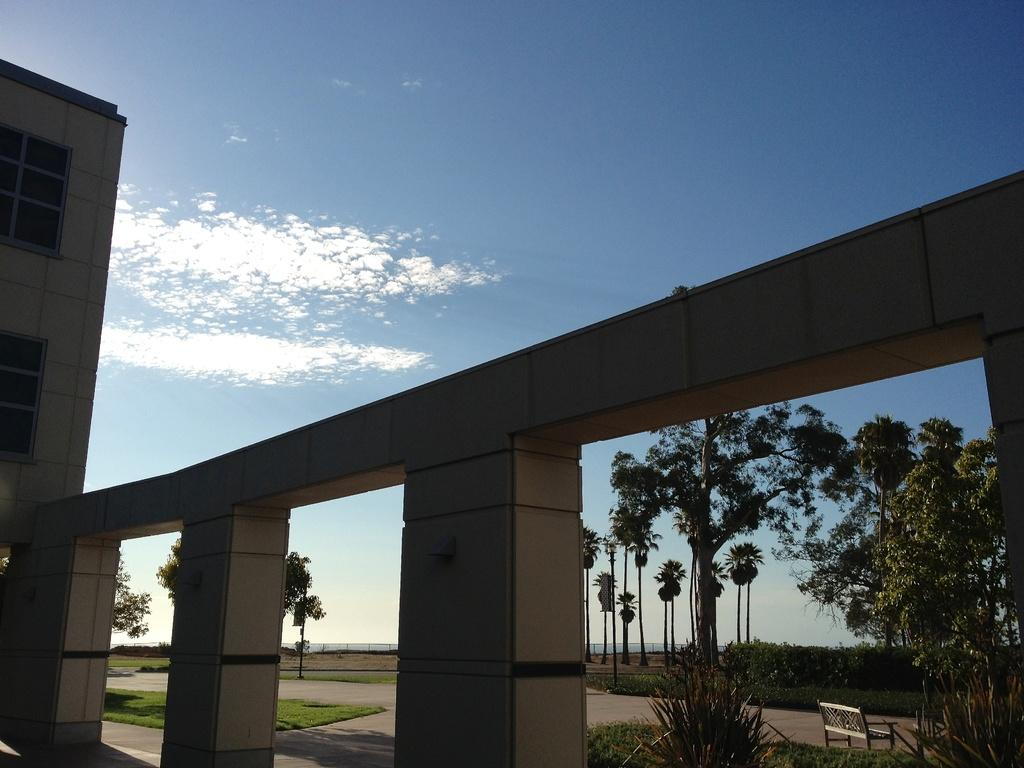What type of structure is visible in the image? There is a building with two windows in the image. What can be seen on the left side of the image? There are trees on the left side of the image. What is placed on the ground in the image? A bench is placed on the ground in the image. What is visible in the background of the image? The sky is visible in the background of the image. What type of fruit is hanging from the trees on the left side of the image? There is no fruit visible in the image; only trees are present on the left side. 